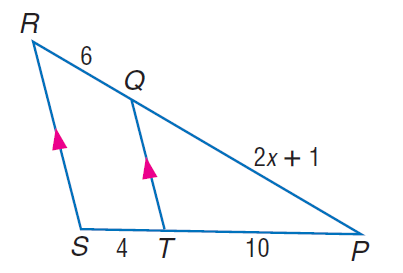Answer the mathemtical geometry problem and directly provide the correct option letter.
Question: Find P Q.
Choices: A: 12 B: 15 C: 16 D: 18 B 